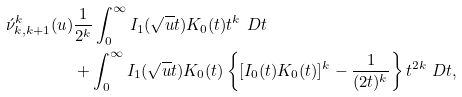<formula> <loc_0><loc_0><loc_500><loc_500>\acute { \nu } ^ { k } _ { k , k + 1 } ( u ) & \frac { 1 } { 2 ^ { k } } \int _ { 0 } ^ { \infty } I _ { 1 } ( \sqrt { u } t ) K _ { 0 } ( t ) t ^ { k } \ D t \\ & + \int _ { 0 } ^ { \infty } I _ { 1 } ( \sqrt { u } t ) K _ { 0 } ( t ) \left \{ [ I _ { 0 } ( t ) K _ { 0 } ( t ) ] ^ { k } - \frac { 1 } { ( 2 t ) ^ { k } } \right \} t ^ { 2 k } \ D t ,</formula> 